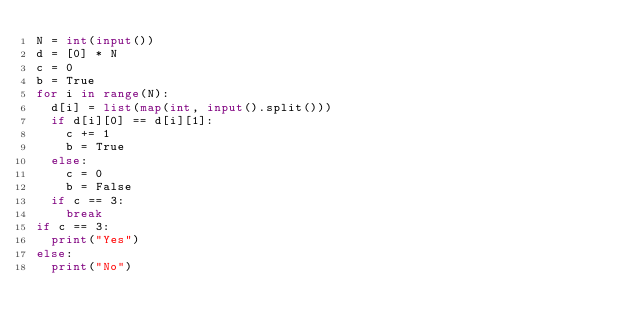Convert code to text. <code><loc_0><loc_0><loc_500><loc_500><_Python_>N = int(input())
d = [0] * N
c = 0
b = True
for i in range(N):
  d[i] = list(map(int, input().split()))
  if d[i][0] == d[i][1]:
    c += 1
    b = True
  else:
    c = 0
    b = False
  if c == 3:
    break
if c == 3:
  print("Yes")
else:
  print("No")</code> 